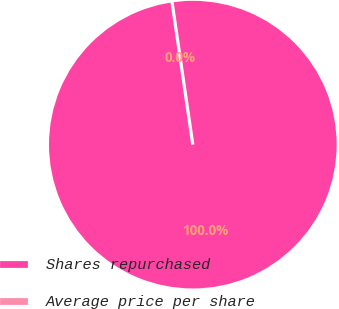Convert chart. <chart><loc_0><loc_0><loc_500><loc_500><pie_chart><fcel>Shares repurchased<fcel>Average price per share<nl><fcel>100.0%<fcel>0.0%<nl></chart> 